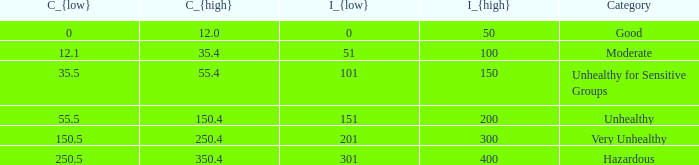What's the C_{low} value when C_{high} is 12.0? 0.0. 